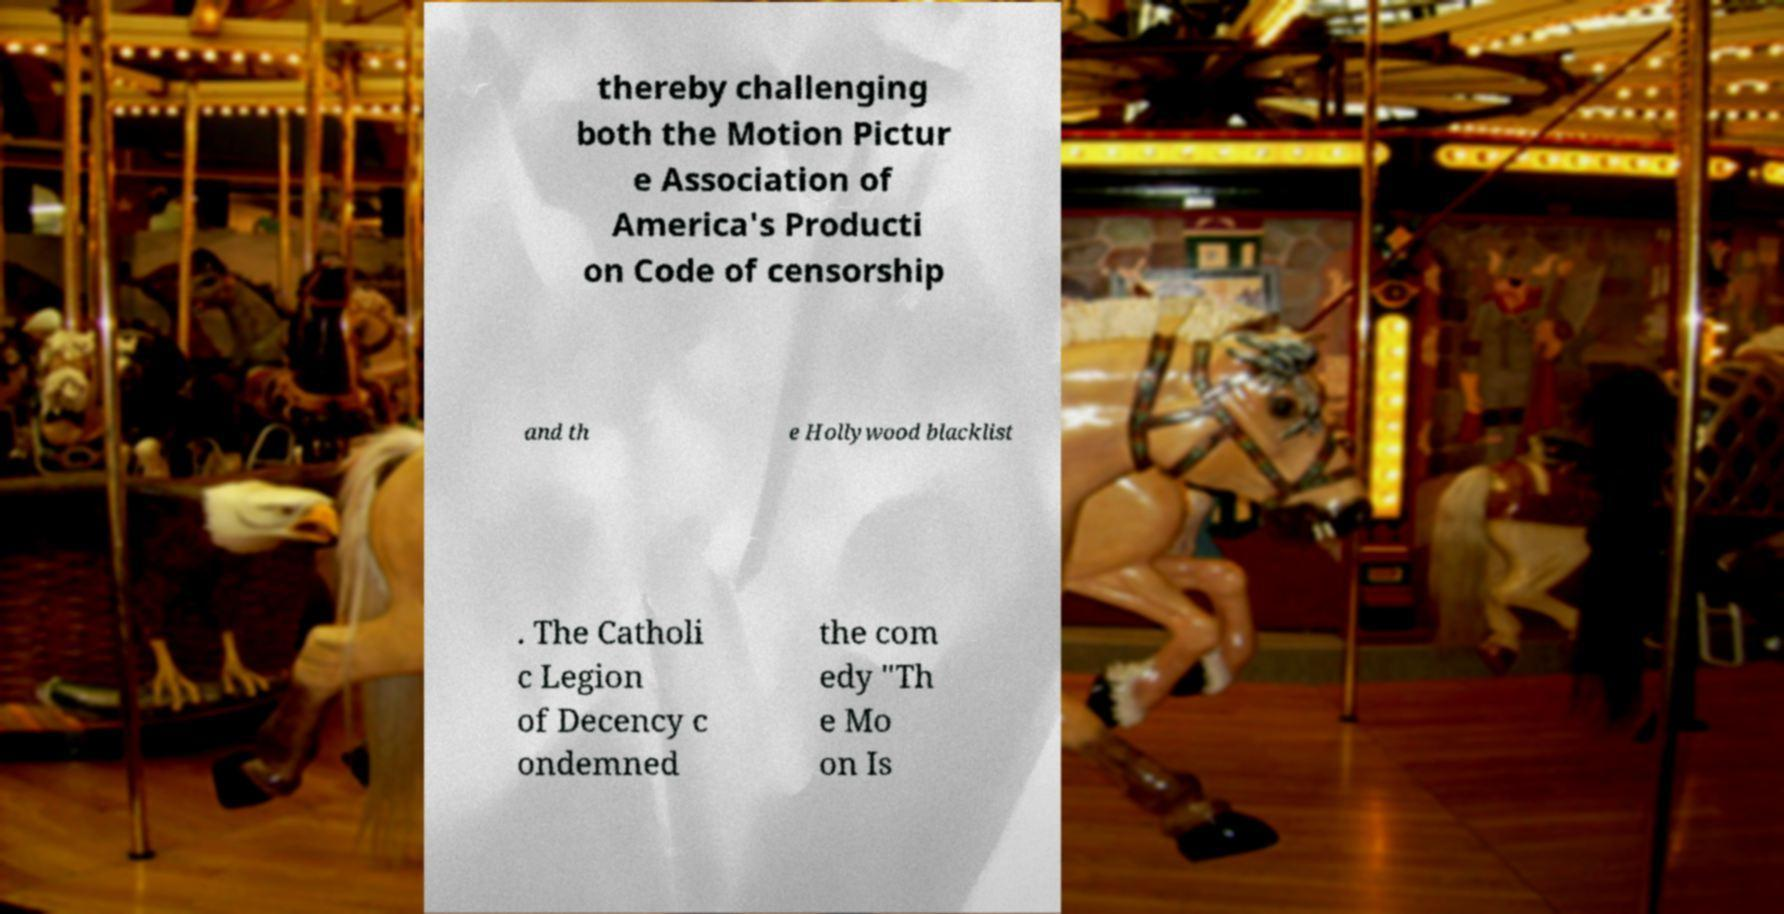For documentation purposes, I need the text within this image transcribed. Could you provide that? thereby challenging both the Motion Pictur e Association of America's Producti on Code of censorship and th e Hollywood blacklist . The Catholi c Legion of Decency c ondemned the com edy "Th e Mo on Is 